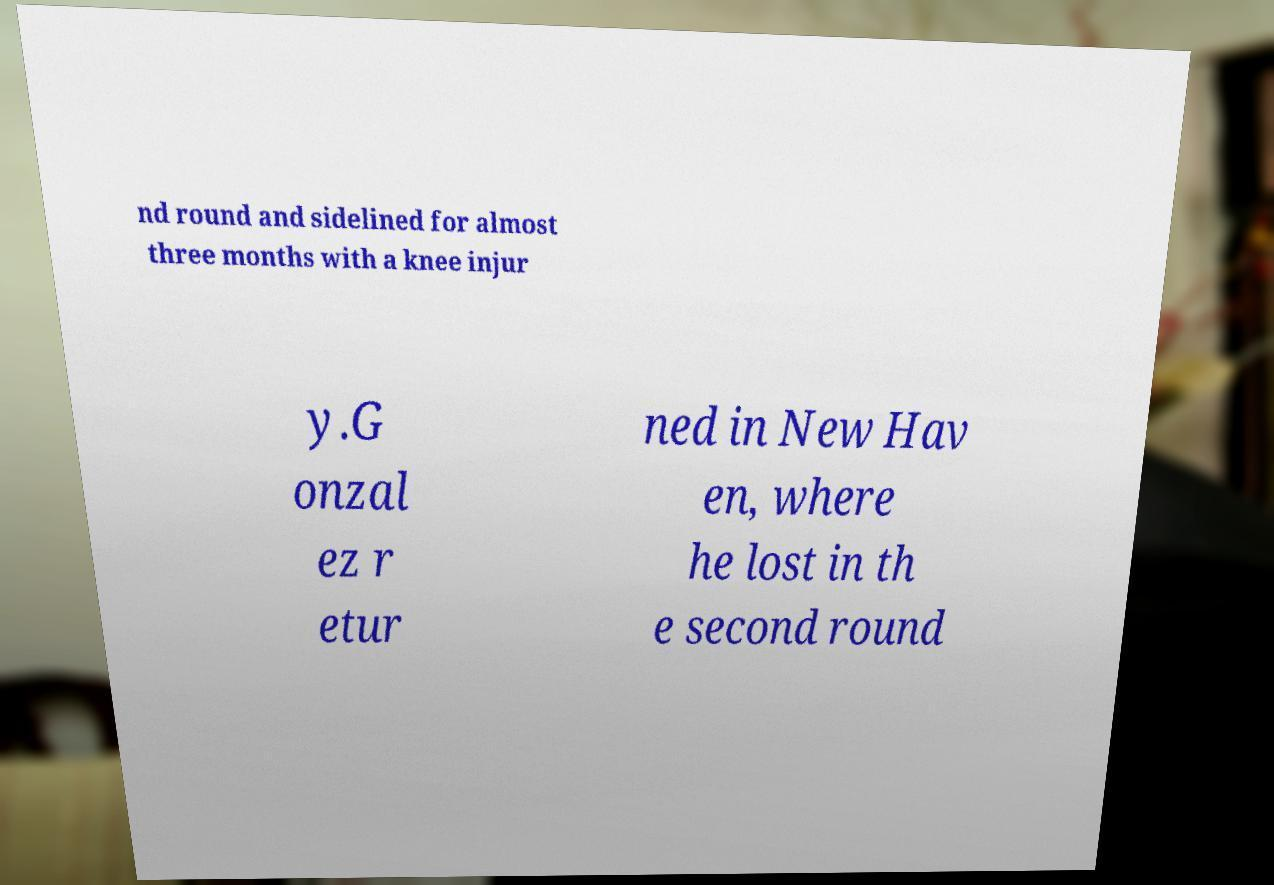Can you read and provide the text displayed in the image?This photo seems to have some interesting text. Can you extract and type it out for me? nd round and sidelined for almost three months with a knee injur y.G onzal ez r etur ned in New Hav en, where he lost in th e second round 